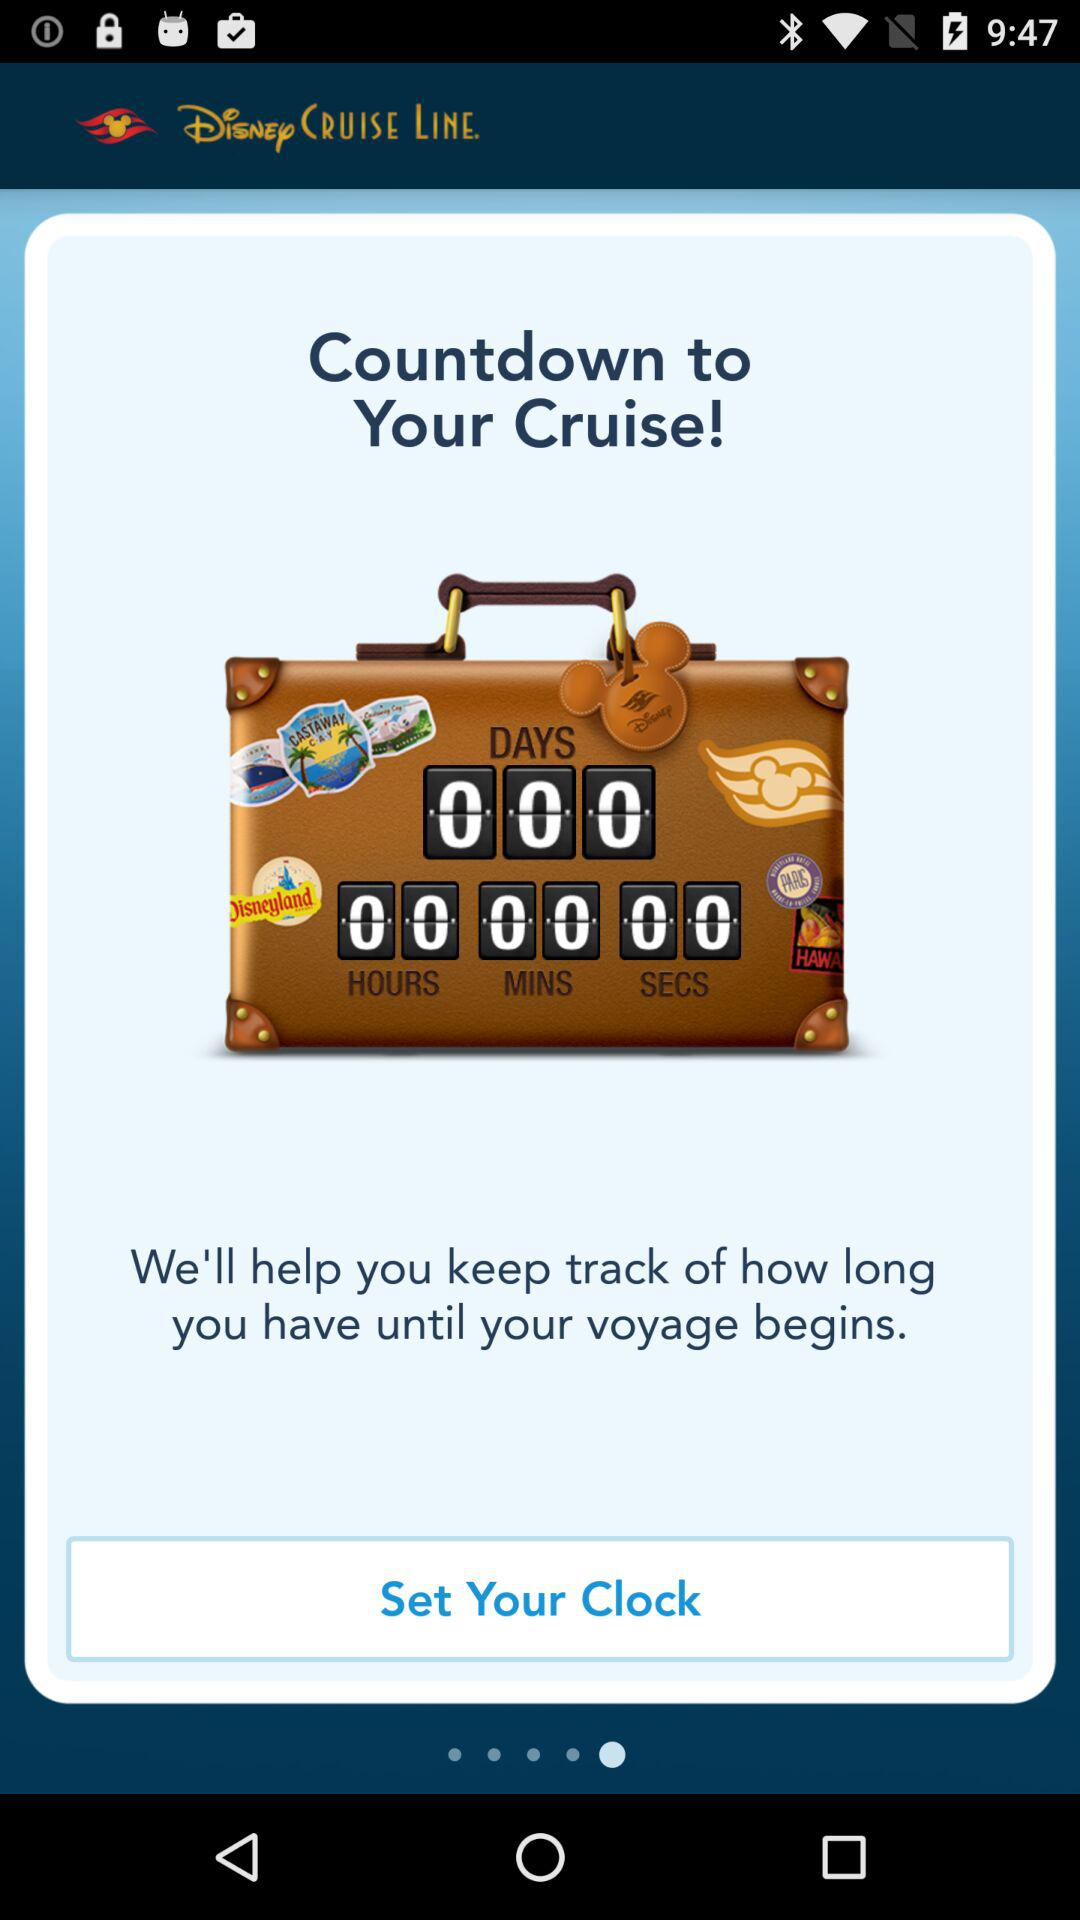How many days are shown there? The shown days are 0. 